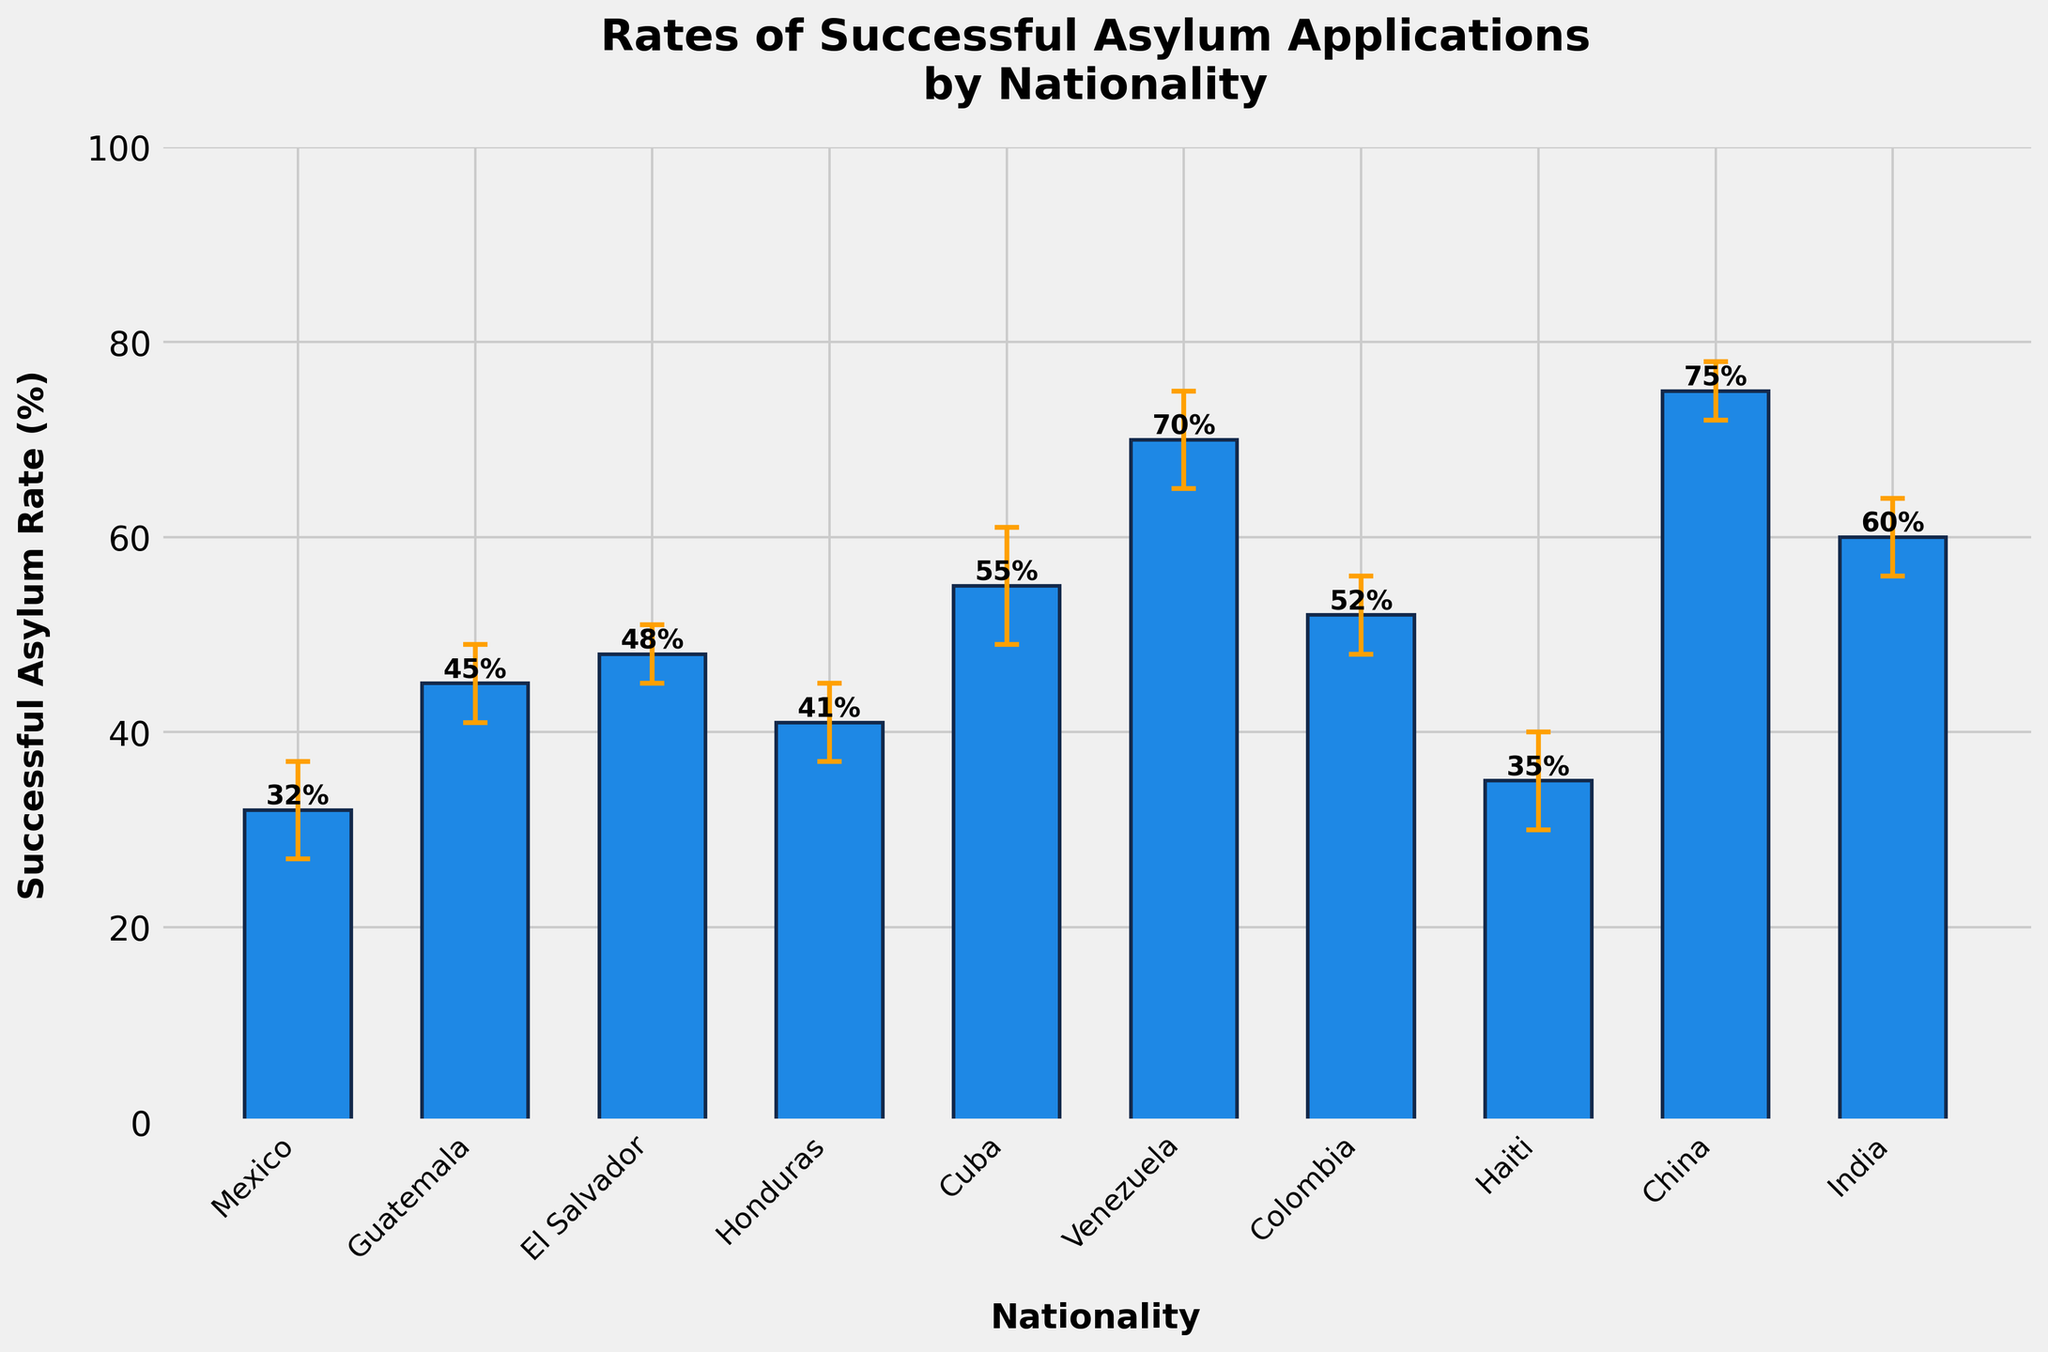What's the title of the figure? The title is displayed at the top of the figure. To find this information, you read the text centered at the top above the graph.
Answer: Rates of Successful Asylum Applications by Nationality Which nationality has the highest successful asylum rate? Look for the tallest bar in the bar chart. The nationality label associated with this bar represents the highest successful rate.
Answer: China What is the successful asylum rate for Mexico? Find the bar labeled "Mexico" on the x-axis and read its height or the text label on the bar.
Answer: 32% How many nationalities have a successful asylum rate above 50%? Identify the bars that reach above the 50% mark by scanning the y-axis ticks and counting them.
Answer: Four Which nationality has the largest error margin? Check each bar's error bars and identify the one with the longest vertical error bar.
Answer: Cuba What is the average successful asylum rate of Guatemala, El Salvador, and Honduras combined? Sum the successful asylum rates of Guatemala (45%), El Salvador (48%), and Honduras (41%), then divide by 3. Calculation: (45 + 48 + 41) / 3 = 44.67%
Answer: 44.67% Compare the successful asylum rates of Venezuela and Colombia. Which is higher and by how much? Refer to the heights of the bars for Venezuela (70%) and Colombia (52%), then subtract the lesser from the greater. Calculation: 70 - 52 = 18%
Answer: Venezuela, by 18% Are there any nationalities with a successful asylum rate within the error margin of Mexico's rate (32% ± 5%)? Mexico's rate with error margin lands between 27% and 37%. Identify any bars whose error bars overlap this range.
Answer: Haiti What's the average error margin across all nationalities? Sum the error margins (5 + 4 + 3 + 4 + 6 + 5 + 4 + 5 + 3 + 4) and divide by the number of nationalities (10). Calculation: (5 + 4 + 3 + 4 + 6 + 5 + 4 + 5 + 3 + 4) / 10 = 4.3%
Answer: 4.3% Between India and Cuba, which nationality has the smaller margin of error? Compare the lengths of the error bars for India (4%) and Cuba (6%), finding the smaller value.
Answer: India 